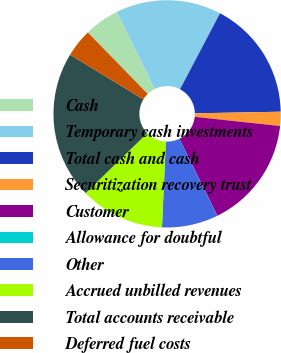<chart> <loc_0><loc_0><loc_500><loc_500><pie_chart><fcel>Cash<fcel>Temporary cash investments<fcel>Total cash and cash<fcel>Securitization recovery trust<fcel>Customer<fcel>Allowance for doubtful<fcel>Other<fcel>Accrued unbilled revenues<fcel>Total accounts receivable<fcel>Deferred fuel costs<nl><fcel>5.0%<fcel>15.0%<fcel>16.99%<fcel>2.01%<fcel>16.0%<fcel>0.01%<fcel>8.0%<fcel>12.0%<fcel>20.99%<fcel>4.0%<nl></chart> 